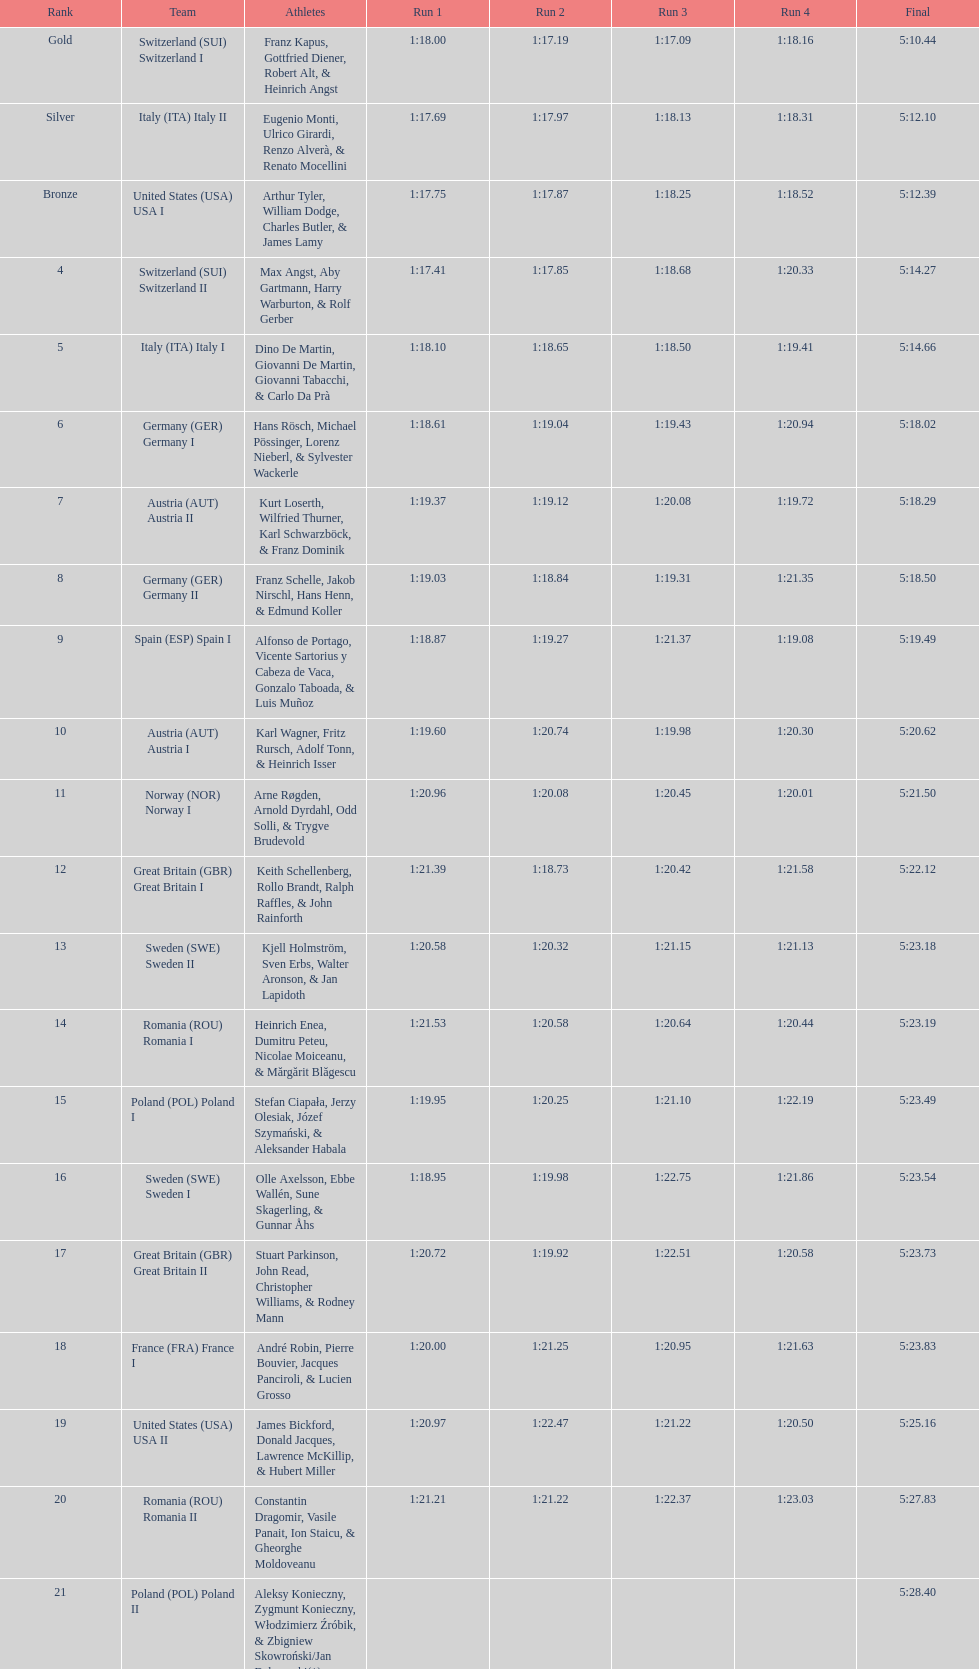How many teams did germany have? 2. 